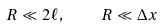Convert formula to latex. <formula><loc_0><loc_0><loc_500><loc_500>R \ll 2 \ell , \quad R \ll \Delta x</formula> 